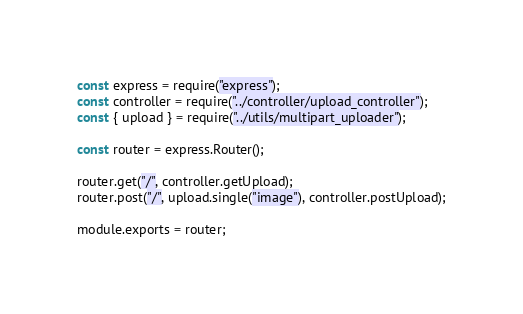<code> <loc_0><loc_0><loc_500><loc_500><_JavaScript_>const express = require("express");
const controller = require("../controller/upload_controller");
const { upload } = require("../utils/multipart_uploader");

const router = express.Router();

router.get("/", controller.getUpload);
router.post("/", upload.single("image"), controller.postUpload);

module.exports = router;
</code> 